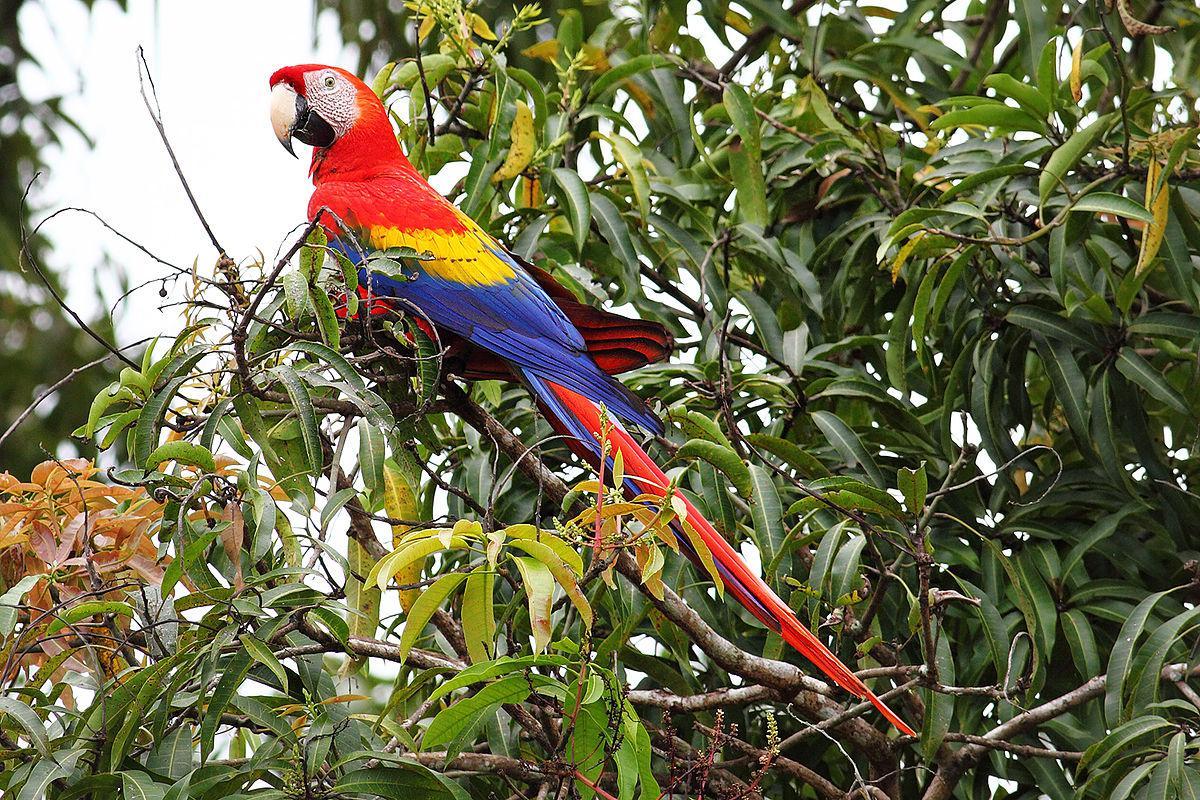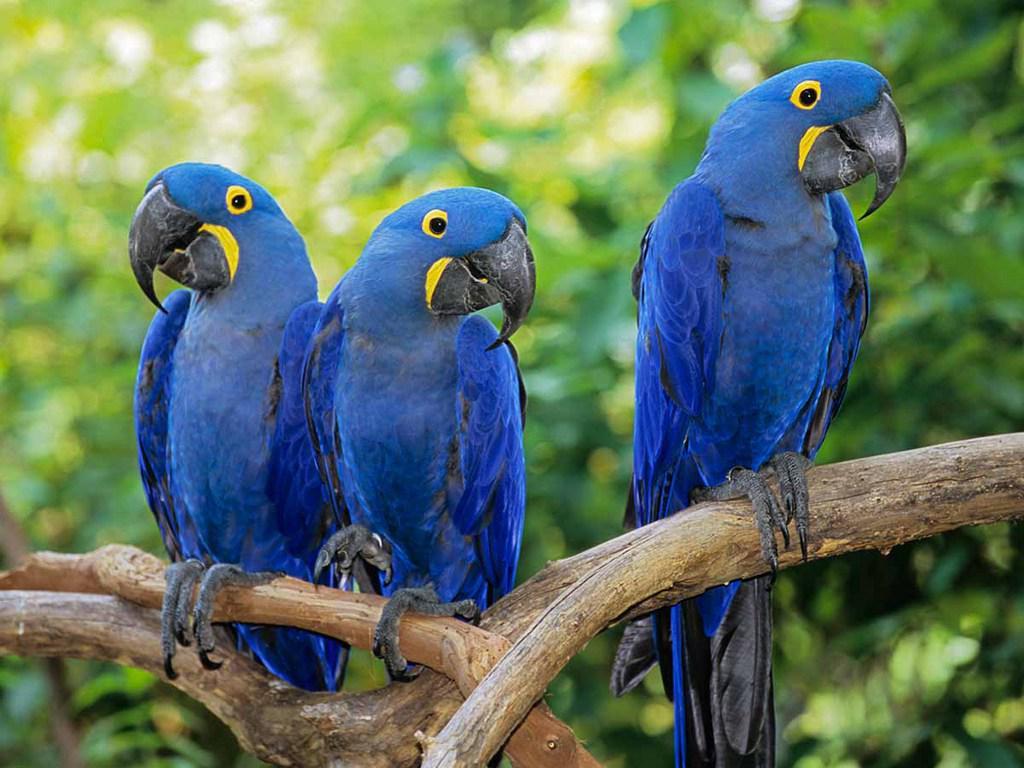The first image is the image on the left, the second image is the image on the right. Analyze the images presented: Is the assertion "In one image, a person is standing in front of a roofed and screened cage area with three different colored parrots perched them." valid? Answer yes or no. No. The first image is the image on the left, the second image is the image on the right. Considering the images on both sides, is "At least one image shows a person with three parrots perched somewhere on their body." valid? Answer yes or no. No. 